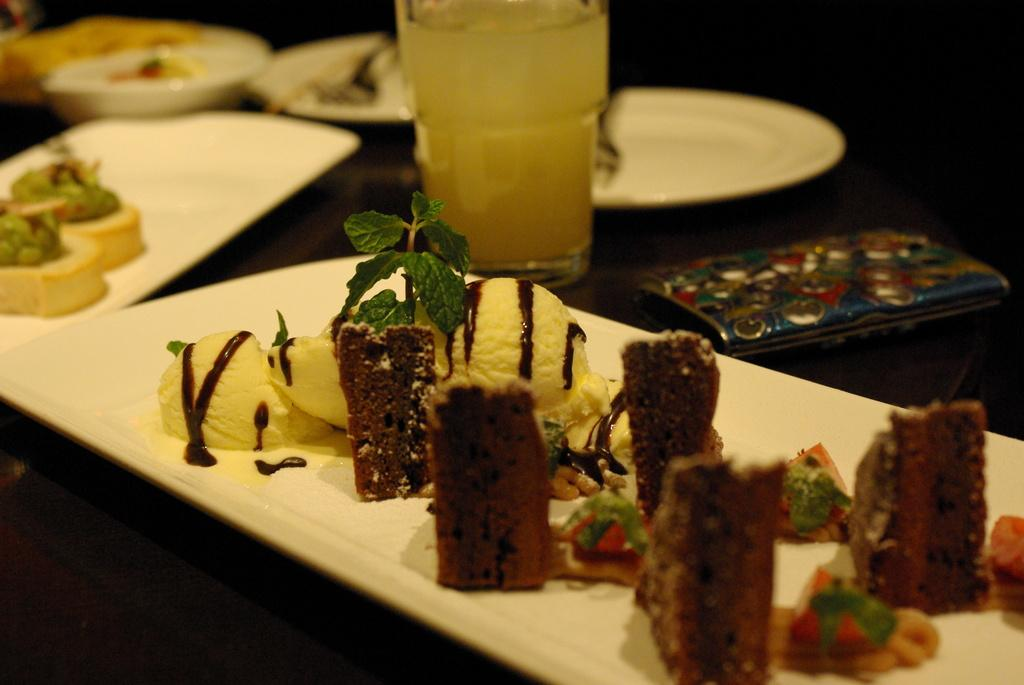What can be seen in the image that represents locations or destinations? There are places in the image. What type of food is visible on the plates in the image? There is food present on plates in the image, but the specific type of food is not mentioned in the facts. What is the drink being served in the image? There is a glass of drink in the image, but the type of drink is not mentioned in the facts. What personal item can be seen on the right side of the image? There is a wallet on the right side of the image. What design is featured on the sweater in the image? There is no sweater present in the image. How many dimes are visible on the table in the image? There are no dimes present in the image. 